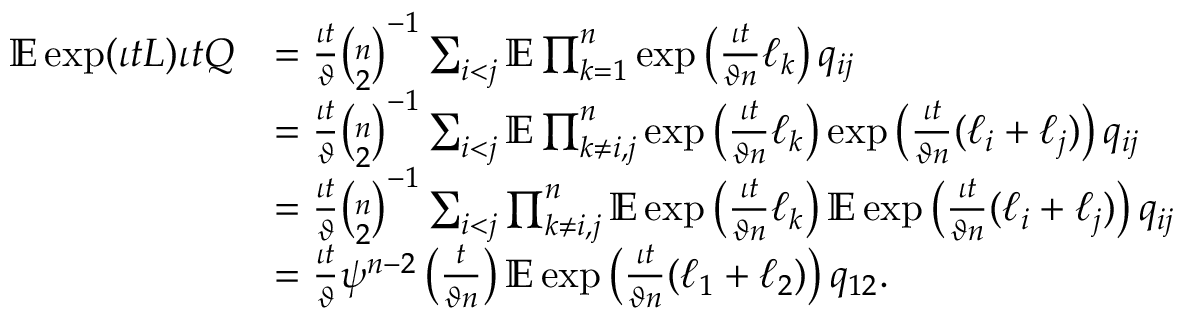Convert formula to latex. <formula><loc_0><loc_0><loc_500><loc_500>\begin{array} { r l } { \mathbb { E } \exp ( \iota t L ) \iota t Q } & { = \frac { \iota t } { \vartheta } \binom { n } { 2 } ^ { - 1 } \sum _ { i < j } \mathbb { E } \prod _ { k = 1 } ^ { n } \exp \left ( \frac { \iota t } { \vartheta n } \ell _ { k } \right ) q _ { i j } } \\ & { = \frac { \iota t } { \vartheta } \binom { n } { 2 } ^ { - 1 } \sum _ { i < j } \mathbb { E } \prod _ { k \neq i , j } ^ { n } \exp \left ( \frac { \iota t } { \vartheta n } \ell _ { k } \right ) \exp \left ( \frac { \iota t } { \vartheta n } ( \ell _ { i } + \ell _ { j } ) \right ) q _ { i j } } \\ & { = \frac { \iota t } { \vartheta } \binom { n } { 2 } ^ { - 1 } \sum _ { i < j } \prod _ { k \neq i , j } ^ { n } \mathbb { E } \exp \left ( \frac { \iota t } { \vartheta n } \ell _ { k } \right ) \mathbb { E } \exp \left ( \frac { \iota t } { \vartheta n } ( \ell _ { i } + \ell _ { j } ) \right ) q _ { i j } } \\ & { = \frac { \iota t } { \vartheta } \psi ^ { n - 2 } \left ( \frac { t } { \vartheta n } \right ) \mathbb { E } \exp \left ( \frac { \iota t } { \vartheta n } ( \ell _ { 1 } + \ell _ { 2 } ) \right ) q _ { 1 2 } . } \end{array}</formula> 